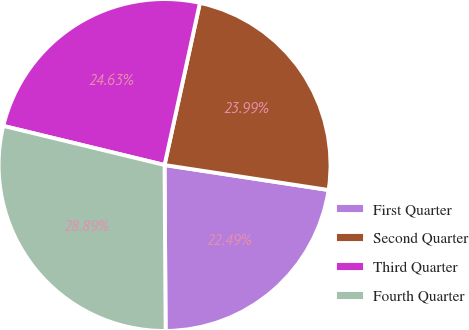<chart> <loc_0><loc_0><loc_500><loc_500><pie_chart><fcel>First Quarter<fcel>Second Quarter<fcel>Third Quarter<fcel>Fourth Quarter<nl><fcel>22.49%<fcel>23.99%<fcel>24.63%<fcel>28.89%<nl></chart> 